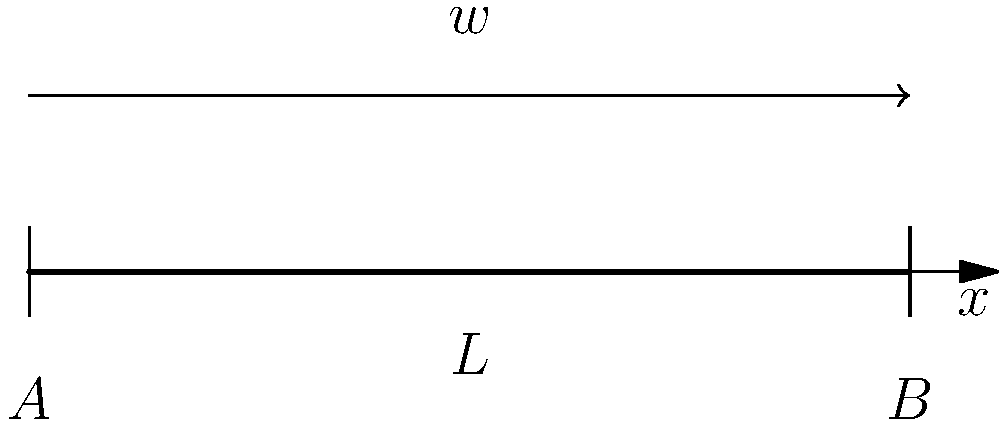Consider a simply supported beam of length $L$ with a uniformly distributed load $w$ per unit length. Determine the expression for the bending moment $M(x)$ at any point $x$ along the beam, and sketch the bending moment diagram. To determine the bending moment expression and diagram:

1. Reaction forces:
   Due to symmetry, $R_A = R_B = \frac{wL}{2}$

2. Bending moment equation:
   For $0 \leq x \leq L$:
   $$M(x) = R_A \cdot x - w \cdot x \cdot \frac{x}{2}$$
   
   Substituting $R_A = \frac{wL}{2}$:
   $$M(x) = \frac{wL}{2} \cdot x - \frac{wx^2}{2}$$

3. Simplify:
   $$M(x) = \frac{wLx}{2} - \frac{wx^2}{2} = \frac{w}{2}(Lx - x^2)$$

4. Maximum bending moment:
   Occurs at $x = \frac{L}{2}$ (midspan)
   $$M_{max} = \frac{wL^2}{8}$$

5. Bending moment diagram:
   The diagram is parabolic, symmetric about the midspan, with:
   - $M(0) = M(L) = 0$ at the supports
   - $M_{max} = \frac{wL^2}{8}$ at $x = \frac{L}{2}$

The bending moment diagram resembles an inverted parabola.
Answer: $M(x) = \frac{w}{2}(Lx - x^2)$, parabolic diagram with $M_{max} = \frac{wL^2}{8}$ at midspan. 